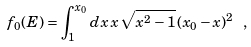Convert formula to latex. <formula><loc_0><loc_0><loc_500><loc_500>f _ { 0 } ( E ) = \int _ { 1 } ^ { x _ { 0 } } d x \, x \, \sqrt { x ^ { 2 } - 1 } \, ( x _ { 0 } - x ) ^ { 2 } \ ,</formula> 